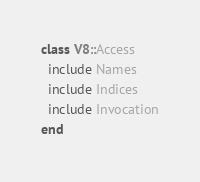<code> <loc_0><loc_0><loc_500><loc_500><_Ruby_>class V8::Access
  include Names
  include Indices
  include Invocation
end</code> 